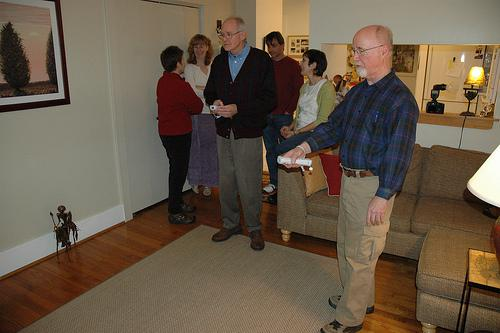Question: what type of flooring does the room have?
Choices:
A. Carpet.
B. Wood.
C. Tile.
D. Bamboo.
Answer with the letter. Answer: B Question: why are the two older men holding controllers?
Choices:
A. Flying a plane.
B. Playing video game.
C. Controlling the tv's.
D. Playing with robots.
Answer with the letter. Answer: B Question: what color belt is the closest man wearing?
Choices:
A. Brown.
B. Black.
C. White.
D. Red.
Answer with the letter. Answer: A Question: where is the sculpture?
Choices:
A. On the table.
B. In the museum.
C. In the water.
D. On floor.
Answer with the letter. Answer: D 